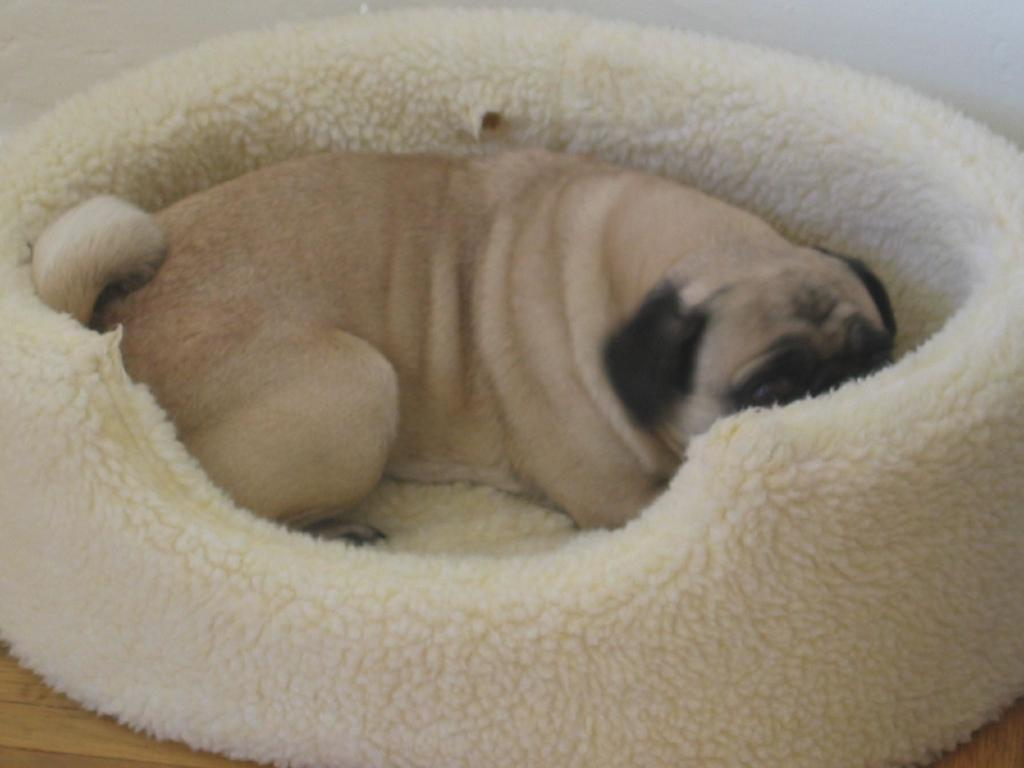What animal can be seen in the image? There is a dog in the image. What is the dog doing in the image? The dog is sleeping. Where is the dog located in the image? The dog is on a bed. What color is the bed in the image? The bed is in cream color. What can be seen in the background of the image? There is a wall in the background of the image. What arithmetic problem is the dog solving in the image? There is no arithmetic problem present in the image, as the dog is sleeping on a bed. What is the dog's profit from playing chess in the image? There is no chess game or profit mentioned in the image, as the dog is simply sleeping on a bed. 